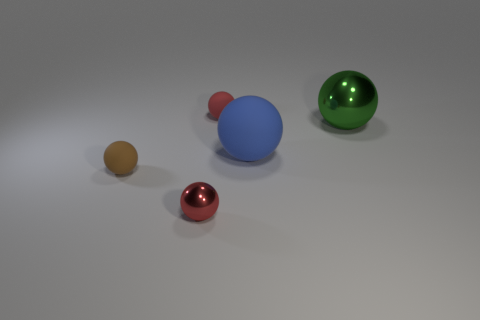How many things are either small things that are behind the blue thing or big yellow matte cylinders?
Make the answer very short. 1. What is the red object in front of the tiny brown object left of the large green metal ball made of?
Offer a terse response. Metal. Are there any green things that have the same material as the brown thing?
Provide a short and direct response. No. Is there a tiny red thing that is behind the brown object that is in front of the large blue object?
Keep it short and to the point. Yes. There is a green ball to the right of the blue object; what is it made of?
Your answer should be compact. Metal. Is the shape of the large matte thing the same as the green metallic object?
Provide a succinct answer. Yes. What color is the small matte sphere that is behind the tiny rubber thing in front of the tiny red sphere that is behind the green sphere?
Offer a terse response. Red. What number of large green metal objects have the same shape as the big blue thing?
Provide a succinct answer. 1. There is a blue ball that is on the right side of the metal sphere to the left of the large shiny object; how big is it?
Give a very brief answer. Large. Does the brown thing have the same size as the blue matte object?
Provide a succinct answer. No. 